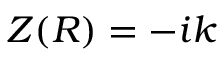Convert formula to latex. <formula><loc_0><loc_0><loc_500><loc_500>Z ( R ) = - i k</formula> 